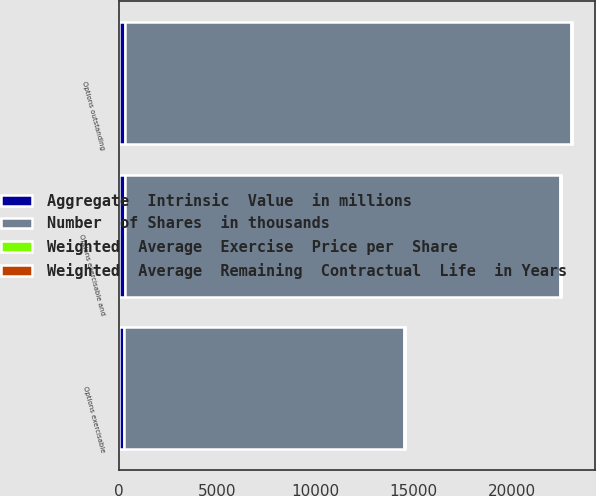Convert chart. <chart><loc_0><loc_0><loc_500><loc_500><stacked_bar_chart><ecel><fcel>Options outstanding<fcel>Options exercisable and<fcel>Options exercisable<nl><fcel>Number  of Shares  in thousands<fcel>22679<fcel>22118<fcel>14271<nl><fcel>Weighted  Average  Remaining  Contractual  Life  in Years<fcel>4.39<fcel>4.34<fcel>3.45<nl><fcel>Weighted  Average  Exercise  Price per  Share<fcel>32.38<fcel>32.12<fcel>28.69<nl><fcel>Aggregate  Intrinsic  Value  in millions<fcel>329<fcel>322<fcel>257<nl></chart> 